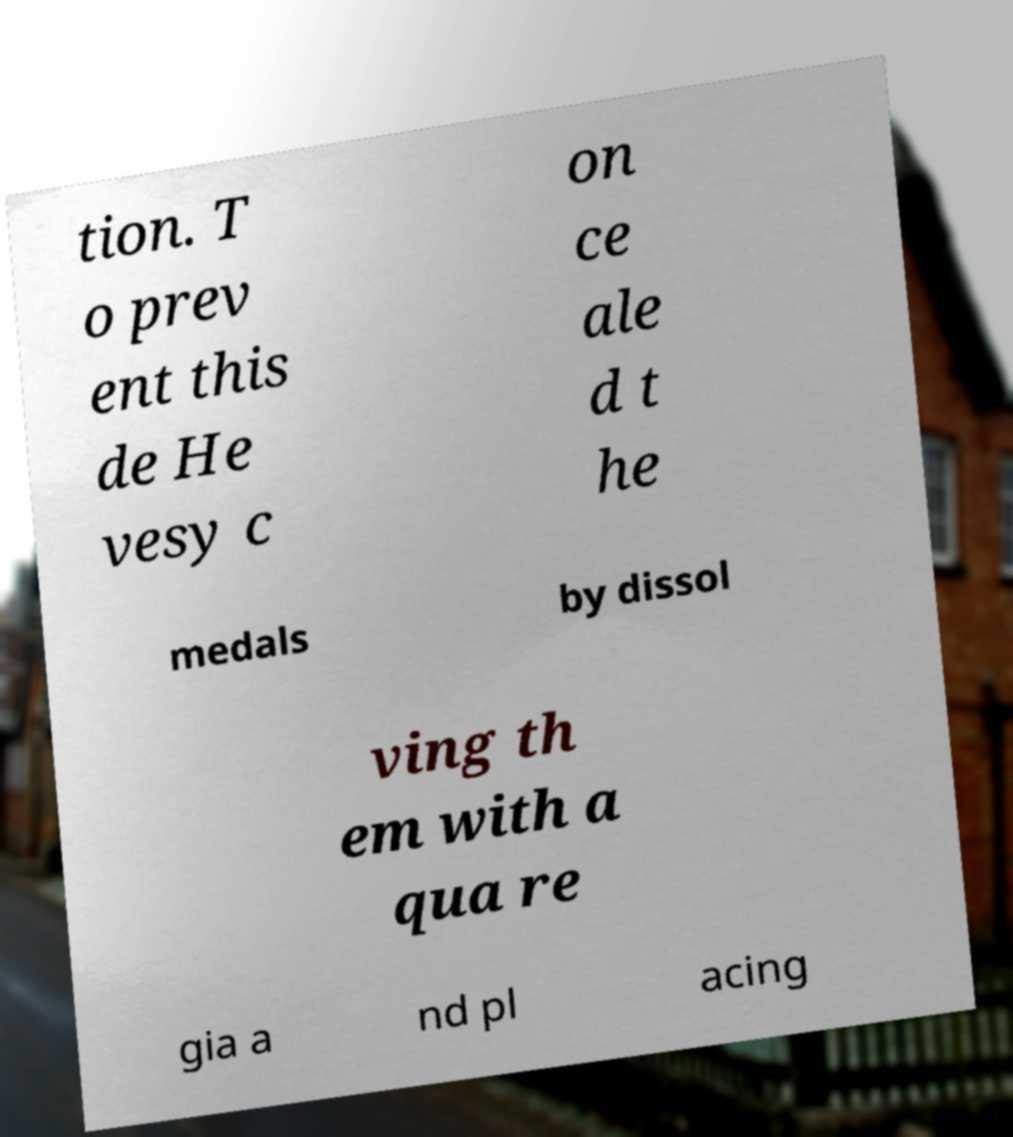Please read and relay the text visible in this image. What does it say? tion. T o prev ent this de He vesy c on ce ale d t he medals by dissol ving th em with a qua re gia a nd pl acing 